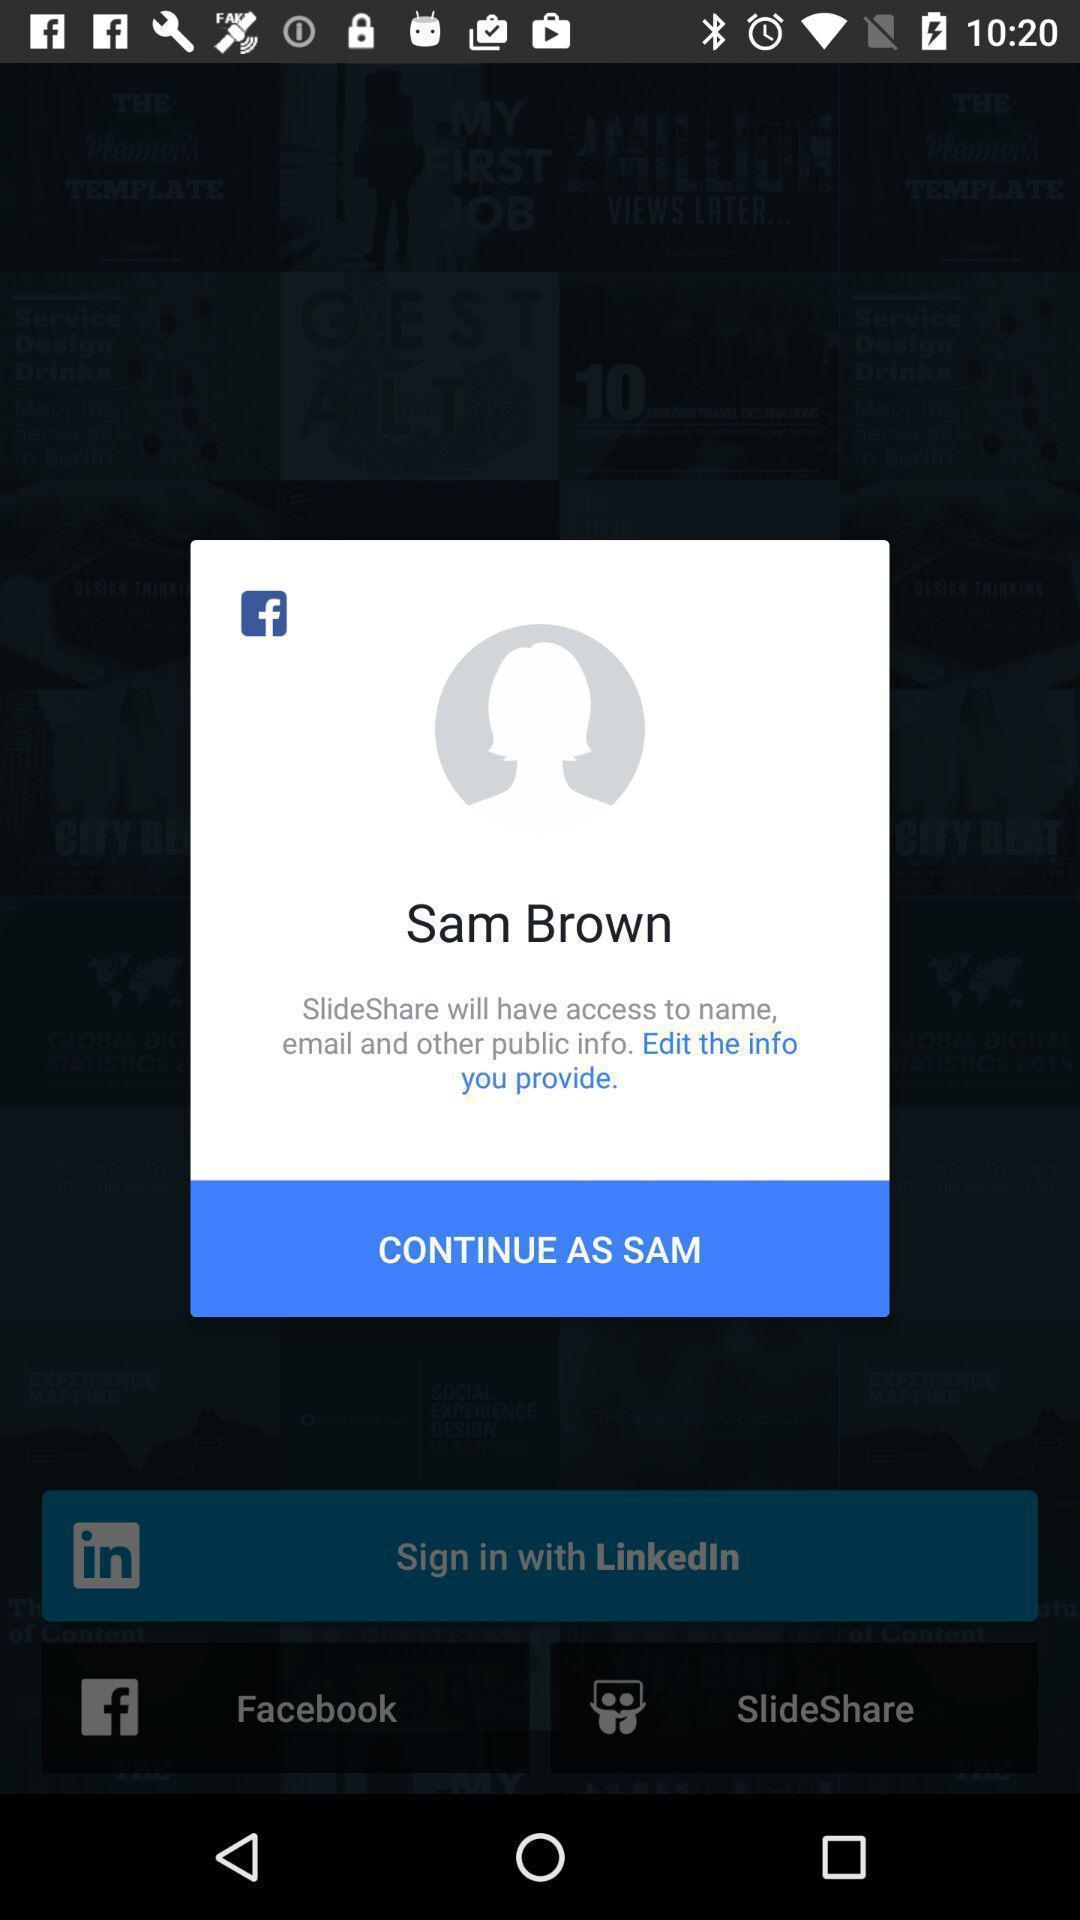What details can you identify in this image? Pop-up showing profile continuation page of a social app. 